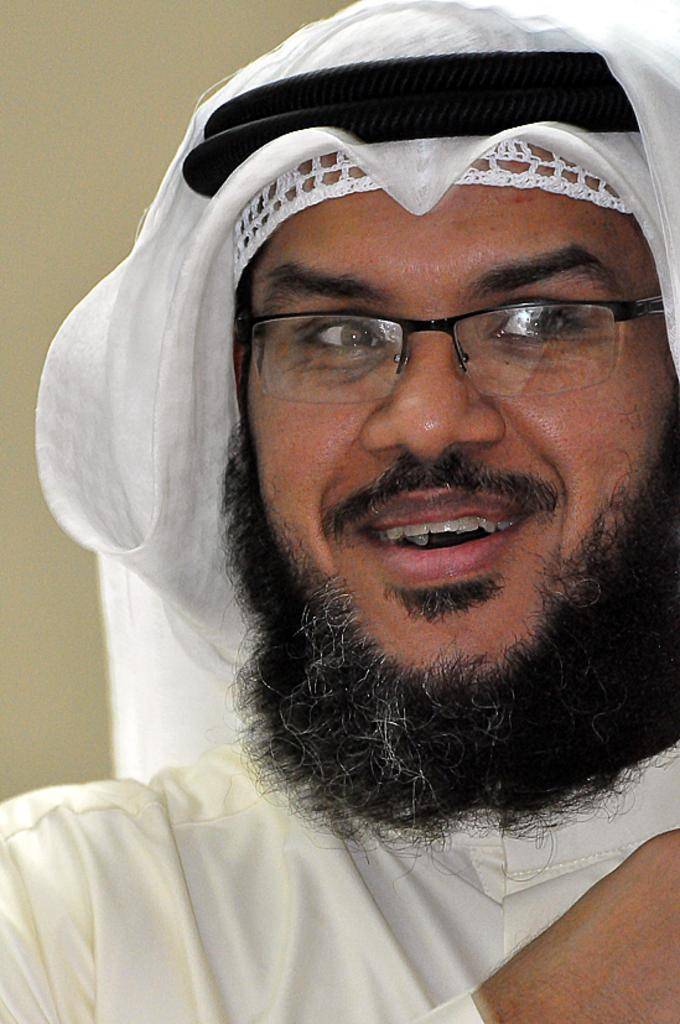Who is present in the image? There is a man in the image. What is the man wearing on his face? The man is wearing glasses (specs) in the image. What color is the man's dress? The man is wearing a white-colored dress in the image. What is on the man's head? There is a white-colored cloth and two black-colored things on the man's head in the image. Where is the faucet located in the image? There is no faucet present in the image. What type of iron is the man holding in the image? There is no iron present in the image. 